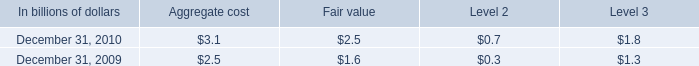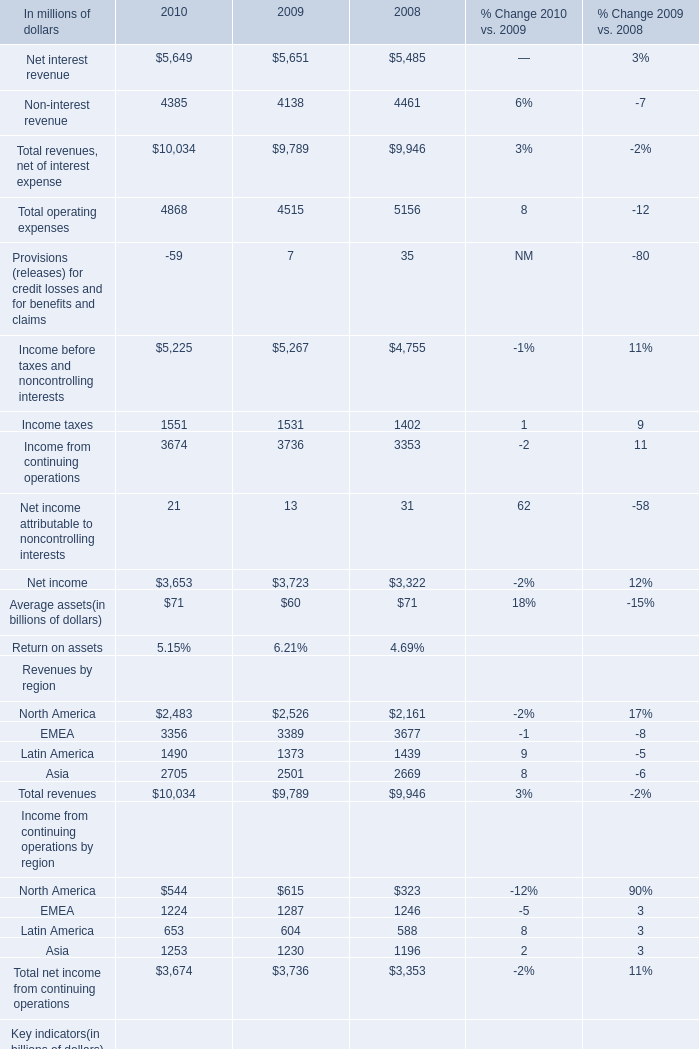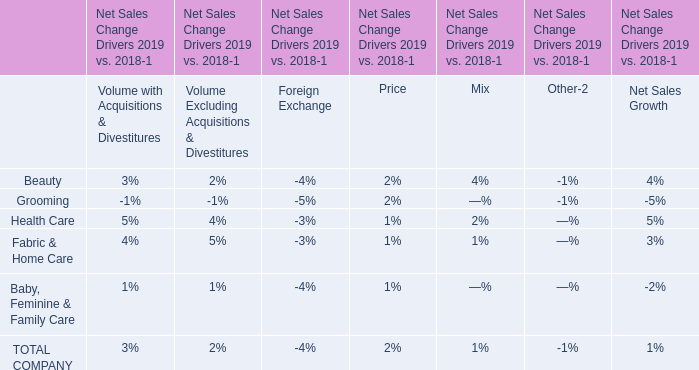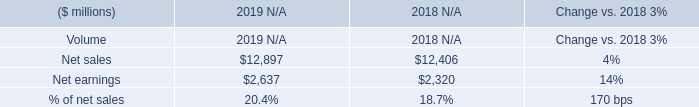What is the growing rate of Non-interest revenue in the year with the most Net interest revenue? (in million) 
Computations: ((4138 - 4461) / 4461)
Answer: -0.07241. 